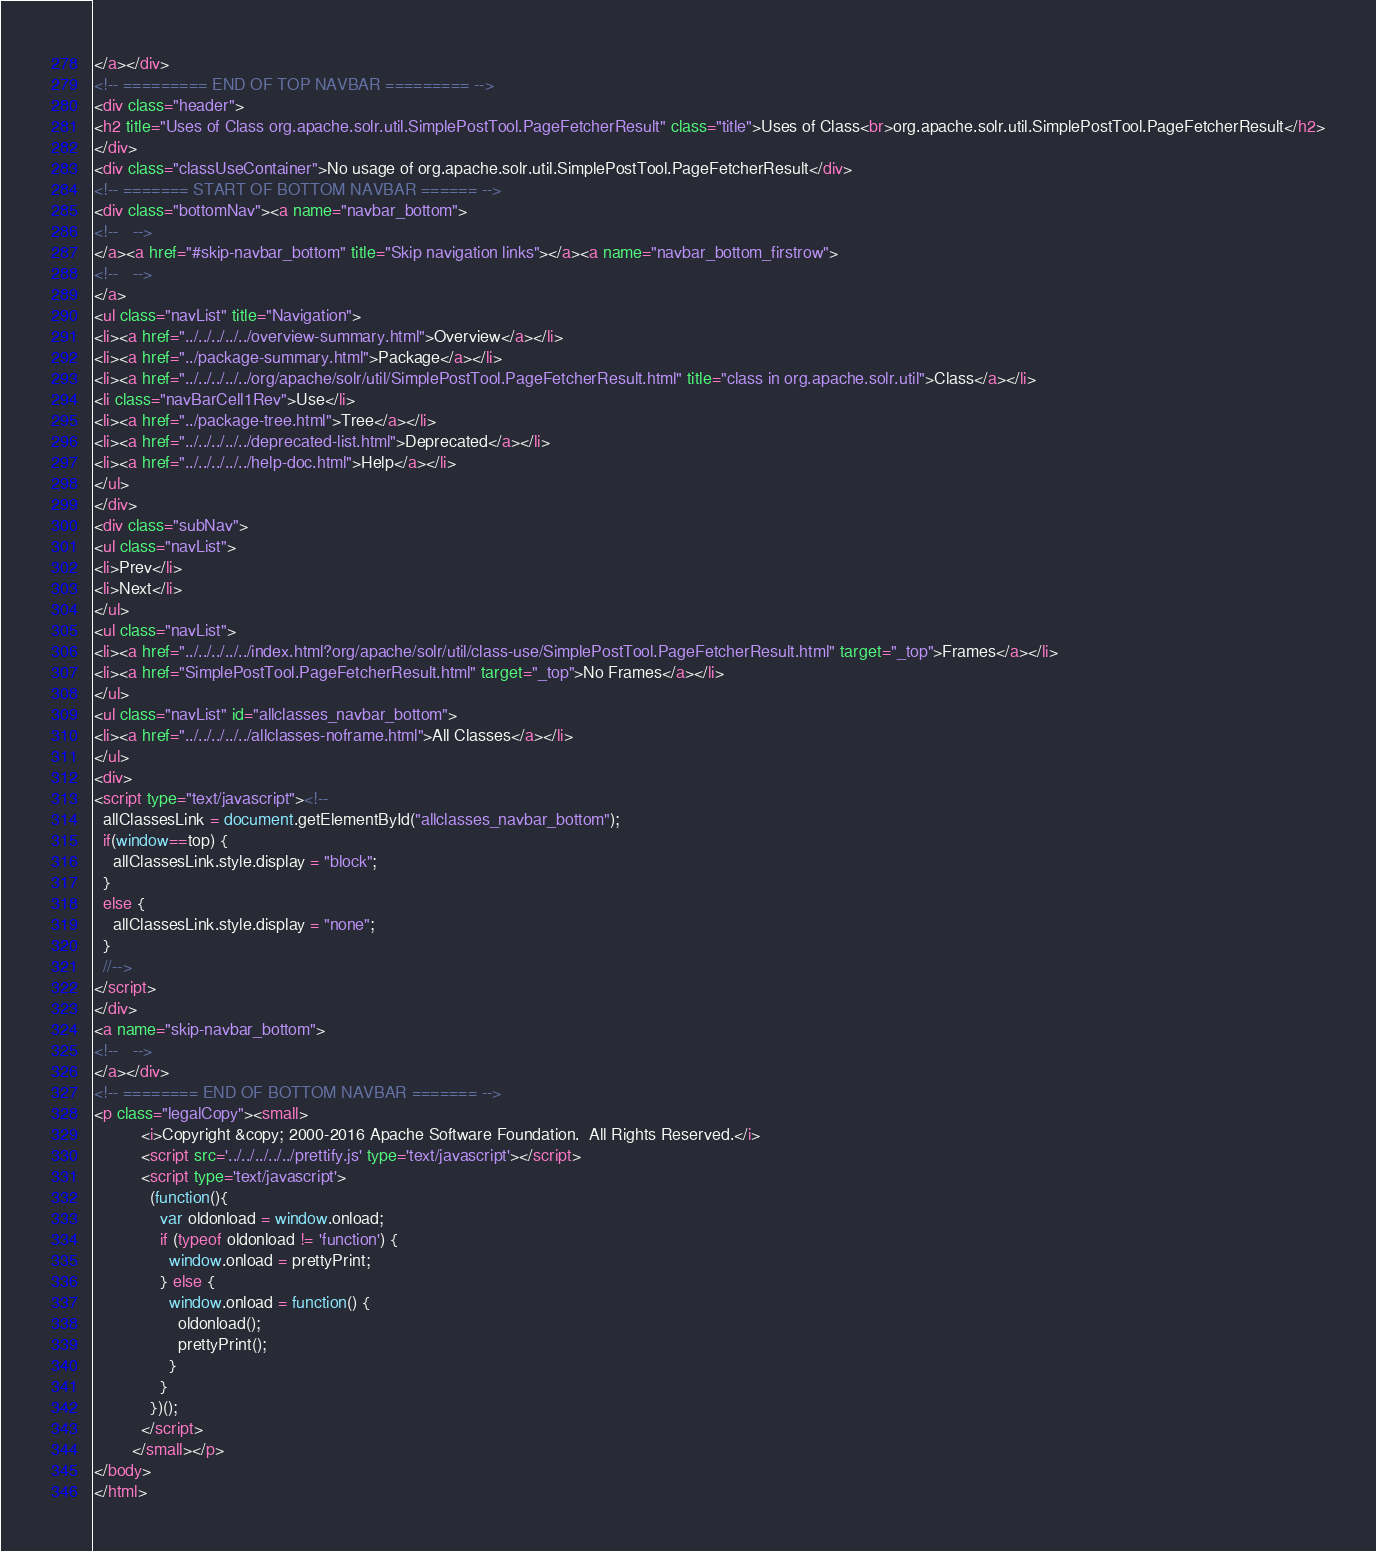<code> <loc_0><loc_0><loc_500><loc_500><_HTML_></a></div>
<!-- ========= END OF TOP NAVBAR ========= -->
<div class="header">
<h2 title="Uses of Class org.apache.solr.util.SimplePostTool.PageFetcherResult" class="title">Uses of Class<br>org.apache.solr.util.SimplePostTool.PageFetcherResult</h2>
</div>
<div class="classUseContainer">No usage of org.apache.solr.util.SimplePostTool.PageFetcherResult</div>
<!-- ======= START OF BOTTOM NAVBAR ====== -->
<div class="bottomNav"><a name="navbar_bottom">
<!--   -->
</a><a href="#skip-navbar_bottom" title="Skip navigation links"></a><a name="navbar_bottom_firstrow">
<!--   -->
</a>
<ul class="navList" title="Navigation">
<li><a href="../../../../../overview-summary.html">Overview</a></li>
<li><a href="../package-summary.html">Package</a></li>
<li><a href="../../../../../org/apache/solr/util/SimplePostTool.PageFetcherResult.html" title="class in org.apache.solr.util">Class</a></li>
<li class="navBarCell1Rev">Use</li>
<li><a href="../package-tree.html">Tree</a></li>
<li><a href="../../../../../deprecated-list.html">Deprecated</a></li>
<li><a href="../../../../../help-doc.html">Help</a></li>
</ul>
</div>
<div class="subNav">
<ul class="navList">
<li>Prev</li>
<li>Next</li>
</ul>
<ul class="navList">
<li><a href="../../../../../index.html?org/apache/solr/util/class-use/SimplePostTool.PageFetcherResult.html" target="_top">Frames</a></li>
<li><a href="SimplePostTool.PageFetcherResult.html" target="_top">No Frames</a></li>
</ul>
<ul class="navList" id="allclasses_navbar_bottom">
<li><a href="../../../../../allclasses-noframe.html">All Classes</a></li>
</ul>
<div>
<script type="text/javascript"><!--
  allClassesLink = document.getElementById("allclasses_navbar_bottom");
  if(window==top) {
    allClassesLink.style.display = "block";
  }
  else {
    allClassesLink.style.display = "none";
  }
  //-->
</script>
</div>
<a name="skip-navbar_bottom">
<!--   -->
</a></div>
<!-- ======== END OF BOTTOM NAVBAR ======= -->
<p class="legalCopy"><small>
          <i>Copyright &copy; 2000-2016 Apache Software Foundation.  All Rights Reserved.</i>
          <script src='../../../../../prettify.js' type='text/javascript'></script>
          <script type='text/javascript'>
            (function(){
              var oldonload = window.onload;
              if (typeof oldonload != 'function') {
                window.onload = prettyPrint;
              } else {
                window.onload = function() {
                  oldonload();
                  prettyPrint();
                }
              }
            })();
          </script>
        </small></p>
</body>
</html>
</code> 